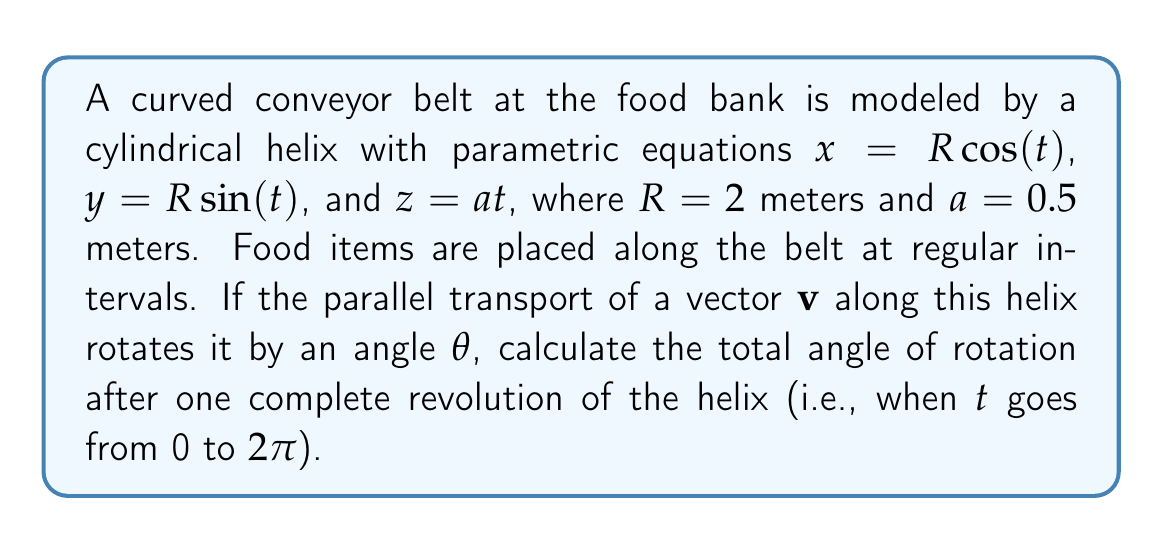Can you answer this question? To solve this problem, we'll follow these steps:

1) The formula for the angle of rotation $\theta$ due to parallel transport along a helix is:

   $$\theta = 2\pi\left(1 - \frac{a}{\sqrt{R^2 + a^2}}\right)$$

   where $a$ is the pitch of the helix and $R$ is its radius.

2) We're given that $R = 2$ meters and $a = 0.5$ meters.

3) Let's substitute these values into the formula:

   $$\theta = 2\pi\left(1 - \frac{0.5}{\sqrt{2^2 + 0.5^2}}\right)$$

4) Simplify the expression under the square root:

   $$\theta = 2\pi\left(1 - \frac{0.5}{\sqrt{4 + 0.25}}\right) = 2\pi\left(1 - \frac{0.5}{\sqrt{4.25}}\right)$$

5) Calculate the square root:

   $$\theta = 2\pi\left(1 - \frac{0.5}{2.0616}\right)$$

6) Perform the division:

   $$\theta = 2\pi(1 - 0.2425) = 2\pi(0.7575)$$

7) Multiply:

   $$\theta = 4.7596 \text{ radians}$$

8) To convert to degrees, multiply by $\frac{180}{\pi}$:

   $$\theta = 4.7596 \cdot \frac{180}{\pi} \approx 272.7°$$
Answer: 272.7° 